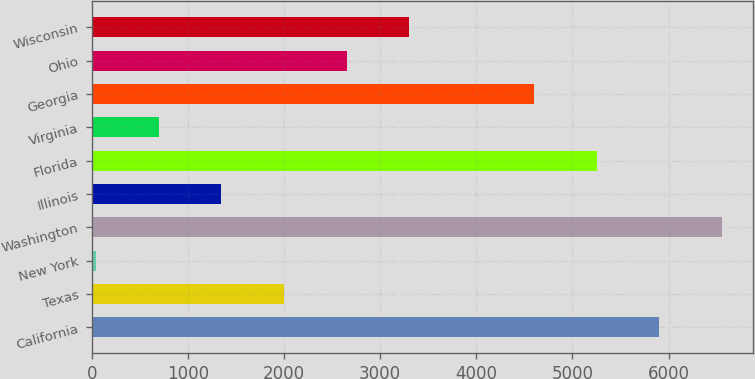Convert chart. <chart><loc_0><loc_0><loc_500><loc_500><bar_chart><fcel>California<fcel>Texas<fcel>New York<fcel>Washington<fcel>Illinois<fcel>Florida<fcel>Virginia<fcel>Georgia<fcel>Ohio<fcel>Wisconsin<nl><fcel>5903.2<fcel>1998.4<fcel>46<fcel>6554<fcel>1347.6<fcel>5252.4<fcel>696.8<fcel>4601.6<fcel>2649.2<fcel>3300<nl></chart> 